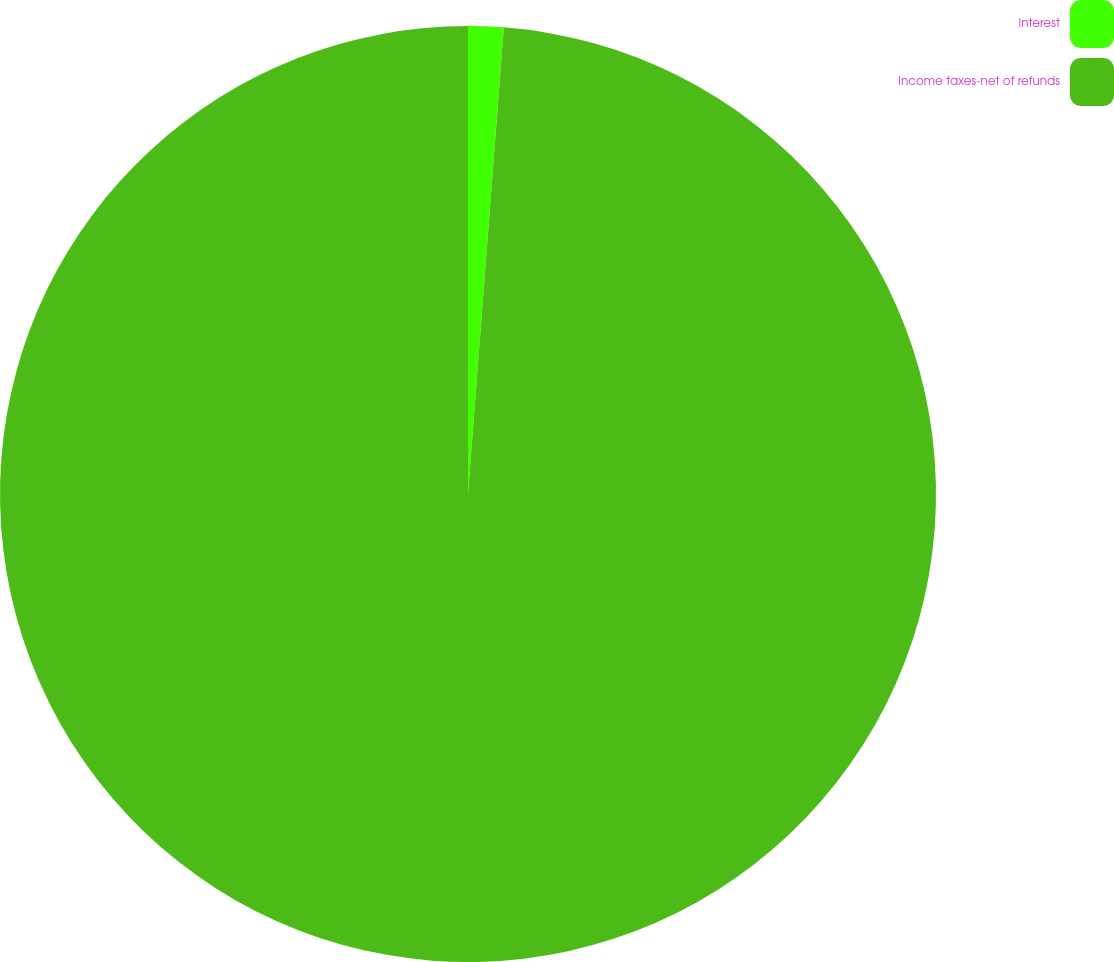Convert chart to OTSL. <chart><loc_0><loc_0><loc_500><loc_500><pie_chart><fcel>Interest<fcel>Income taxes-net of refunds<nl><fcel>1.22%<fcel>98.78%<nl></chart> 